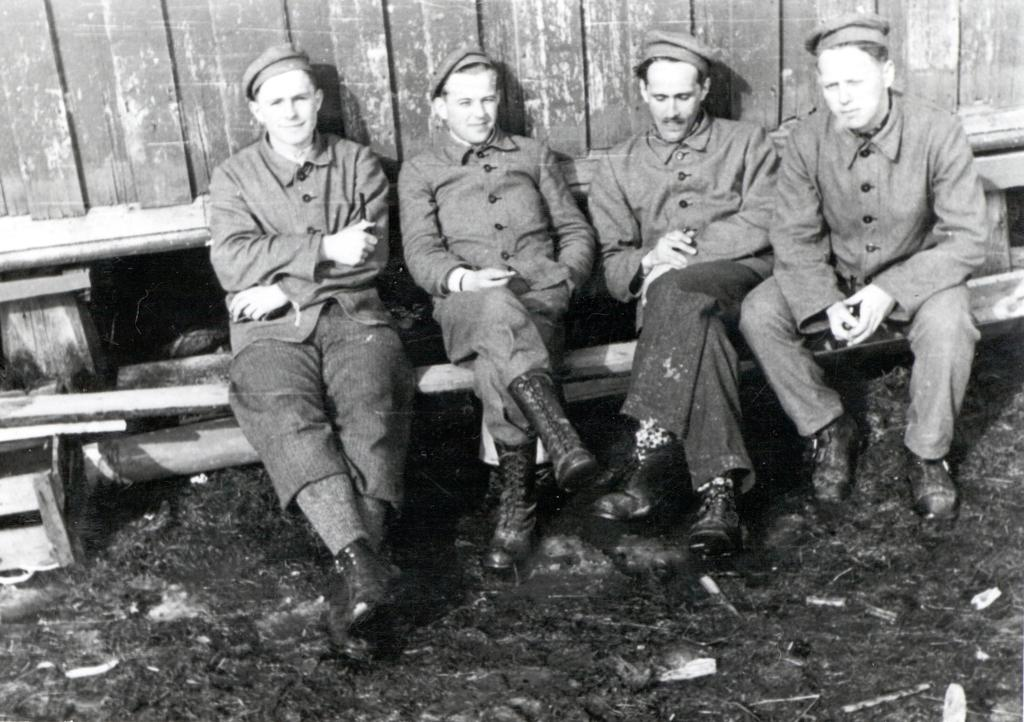What type of picture is in the image? The image contains a black and white picture. How many people are in the picture? There are four people in the picture. What are the people wearing? The people are wearing uniforms. What are the people sitting on in the picture? The people are sitting on a wooden bench. What can be seen in the background of the picture? There is a wooden wall in the background of the picture. What type of fish is swimming in the picture? There is no fish present in the picture; it contains a black and white picture of four people sitting on a wooden bench. 